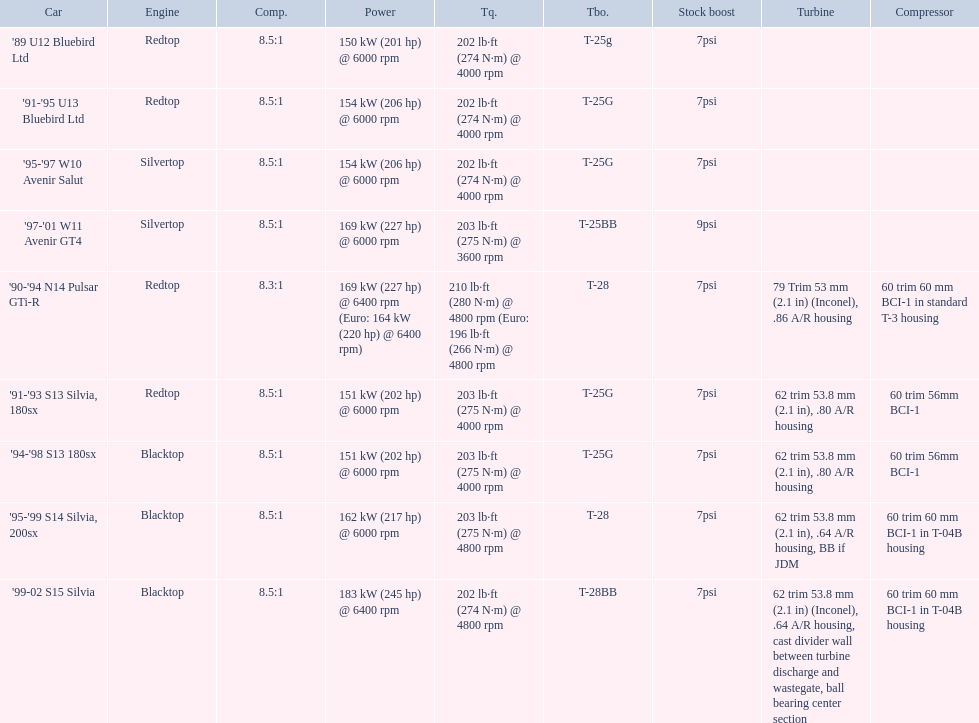What cars are there? '89 U12 Bluebird Ltd, 7psi, '91-'95 U13 Bluebird Ltd, 7psi, '95-'97 W10 Avenir Salut, 7psi, '97-'01 W11 Avenir GT4, 9psi, '90-'94 N14 Pulsar GTi-R, 7psi, '91-'93 S13 Silvia, 180sx, 7psi, '94-'98 S13 180sx, 7psi, '95-'99 S14 Silvia, 200sx, 7psi, '99-02 S15 Silvia, 7psi. Which stock boost is over 7psi? '97-'01 W11 Avenir GT4, 9psi. What car is it? '97-'01 W11 Avenir GT4. 